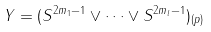Convert formula to latex. <formula><loc_0><loc_0><loc_500><loc_500>Y = ( S ^ { 2 m _ { 1 } - 1 } \vee \dots \vee S ^ { 2 m _ { l } - 1 } ) _ { ( p ) }</formula> 